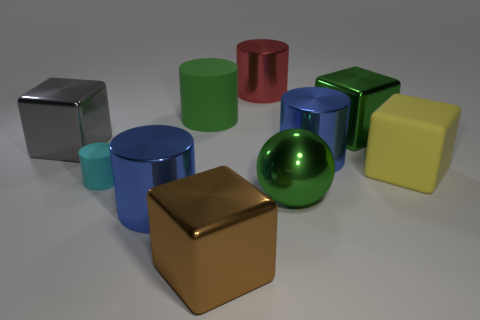Subtract all green shiny blocks. How many blocks are left? 3 Subtract all cubes. How many objects are left? 6 Subtract 3 cubes. How many cubes are left? 1 Subtract all red cylinders. How many cylinders are left? 4 Add 7 red things. How many red things are left? 8 Add 2 small blue rubber balls. How many small blue rubber balls exist? 2 Subtract 1 red cylinders. How many objects are left? 9 Subtract all cyan spheres. Subtract all brown blocks. How many spheres are left? 1 Subtract all gray cubes. How many purple cylinders are left? 0 Subtract all metallic spheres. Subtract all large balls. How many objects are left? 8 